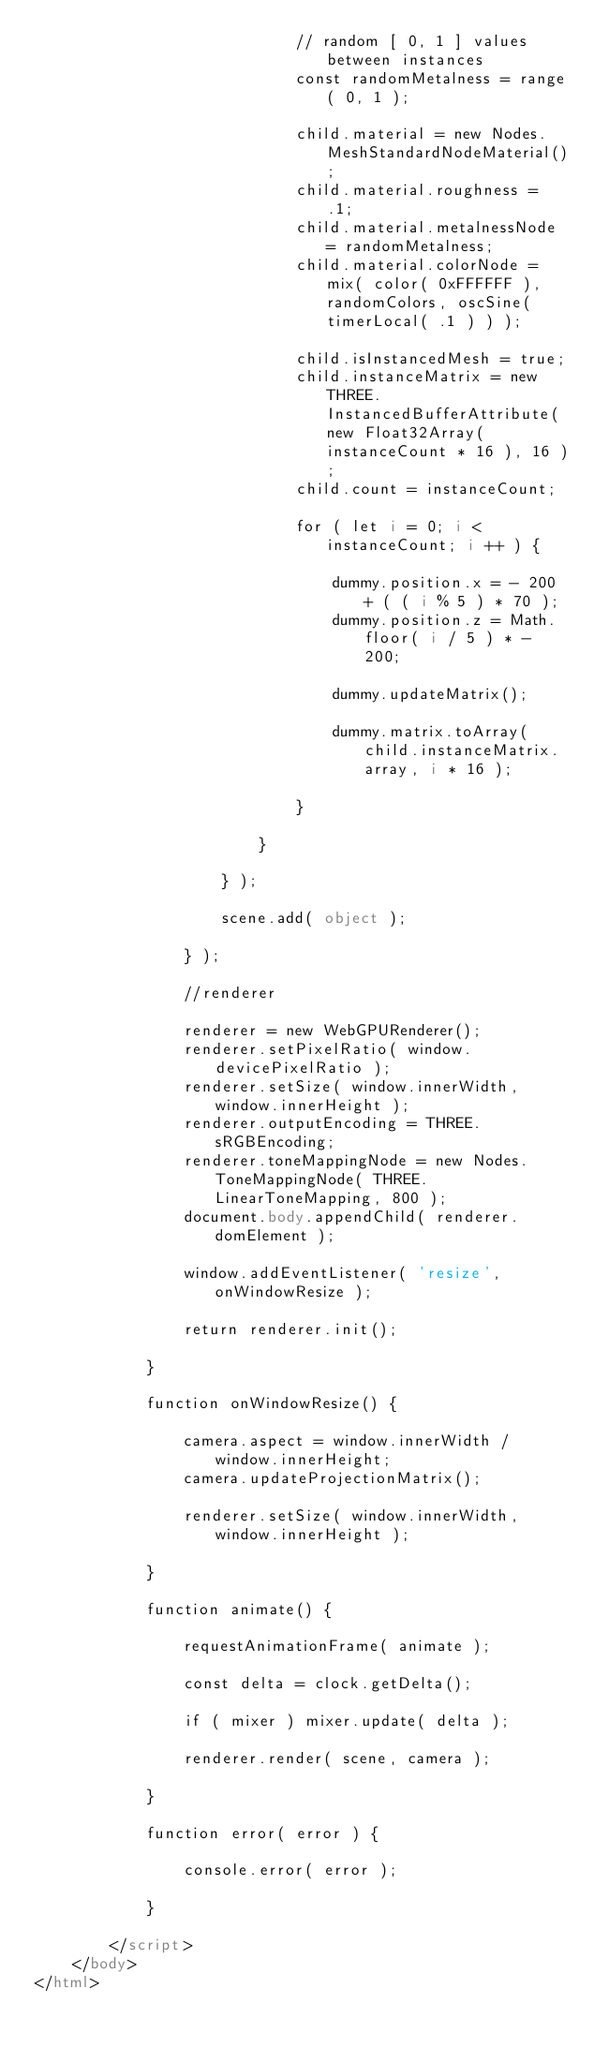<code> <loc_0><loc_0><loc_500><loc_500><_HTML_>							// random [ 0, 1 ] values between instances
							const randomMetalness = range( 0, 1 );

							child.material = new Nodes.MeshStandardNodeMaterial();
							child.material.roughness = .1;
							child.material.metalnessNode = randomMetalness;
							child.material.colorNode =  mix( color( 0xFFFFFF ), randomColors, oscSine( timerLocal( .1 ) ) );

							child.isInstancedMesh = true;
							child.instanceMatrix = new THREE.InstancedBufferAttribute( new Float32Array( instanceCount * 16 ), 16 );
							child.count = instanceCount;

							for ( let i = 0; i < instanceCount; i ++ ) {

								dummy.position.x = - 200 + ( ( i % 5 ) * 70 );
								dummy.position.z = Math.floor( i / 5 ) * - 200;

								dummy.updateMatrix();

								dummy.matrix.toArray( child.instanceMatrix.array, i * 16 );

							}

						}

					} );

					scene.add( object );

				} );

				//renderer

				renderer = new WebGPURenderer();
				renderer.setPixelRatio( window.devicePixelRatio );
				renderer.setSize( window.innerWidth, window.innerHeight );
				renderer.outputEncoding = THREE.sRGBEncoding;
				renderer.toneMappingNode = new Nodes.ToneMappingNode( THREE.LinearToneMapping, 800 );
				document.body.appendChild( renderer.domElement );

				window.addEventListener( 'resize', onWindowResize );

				return renderer.init();

			}

			function onWindowResize() {

				camera.aspect = window.innerWidth / window.innerHeight;
				camera.updateProjectionMatrix();

				renderer.setSize( window.innerWidth, window.innerHeight );

			}

			function animate() {

				requestAnimationFrame( animate );

				const delta = clock.getDelta();

				if ( mixer ) mixer.update( delta );

				renderer.render( scene, camera );

			}

			function error( error ) {

				console.error( error );

			}

		</script>
	</body>
</html>
</code> 